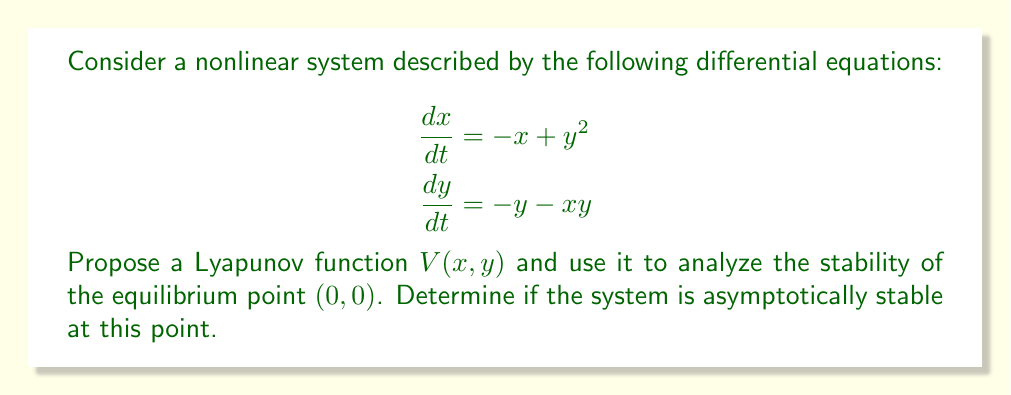Could you help me with this problem? Let's approach this step-by-step:

1) First, we need to propose a Lyapunov function. For this system, let's try:

   $$V(x,y) = \frac{1}{2}(x^2 + y^2)$$

2) To prove stability, we need to show that $V(x,y)$ is positive definite and its derivative $\dot{V}(x,y)$ is negative definite.

3) Clearly, $V(x,y)$ is positive definite as it's always positive except at $(0,0)$ where it's zero.

4) Now, let's calculate $\dot{V}(x,y)$:

   $$\begin{aligned}
   \dot{V}(x,y) &= \frac{\partial V}{\partial x}\frac{dx}{dt} + \frac{\partial V}{\partial y}\frac{dy}{dt} \\
   &= x(-x+y^2) + y(-y-xy) \\
   &= -x^2 + xy^2 - y^2 - xy^2 \\
   &= -x^2 - y^2
   \end{aligned}$$

5) We can see that $\dot{V}(x,y)$ is negative definite, as it's always negative except at $(0,0)$ where it's zero.

6) Since $V(x,y)$ is positive definite and $\dot{V}(x,y)$ is negative definite, by Lyapunov's stability theorem, the equilibrium point $(0,0)$ is asymptotically stable.

This means that all solutions starting close enough to $(0,0)$ will converge to $(0,0)$ as $t \to \infty$.
Answer: The system is asymptotically stable at $(0,0)$. 